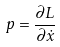<formula> <loc_0><loc_0><loc_500><loc_500>p = \frac { \partial L } { \partial \dot { x } }</formula> 